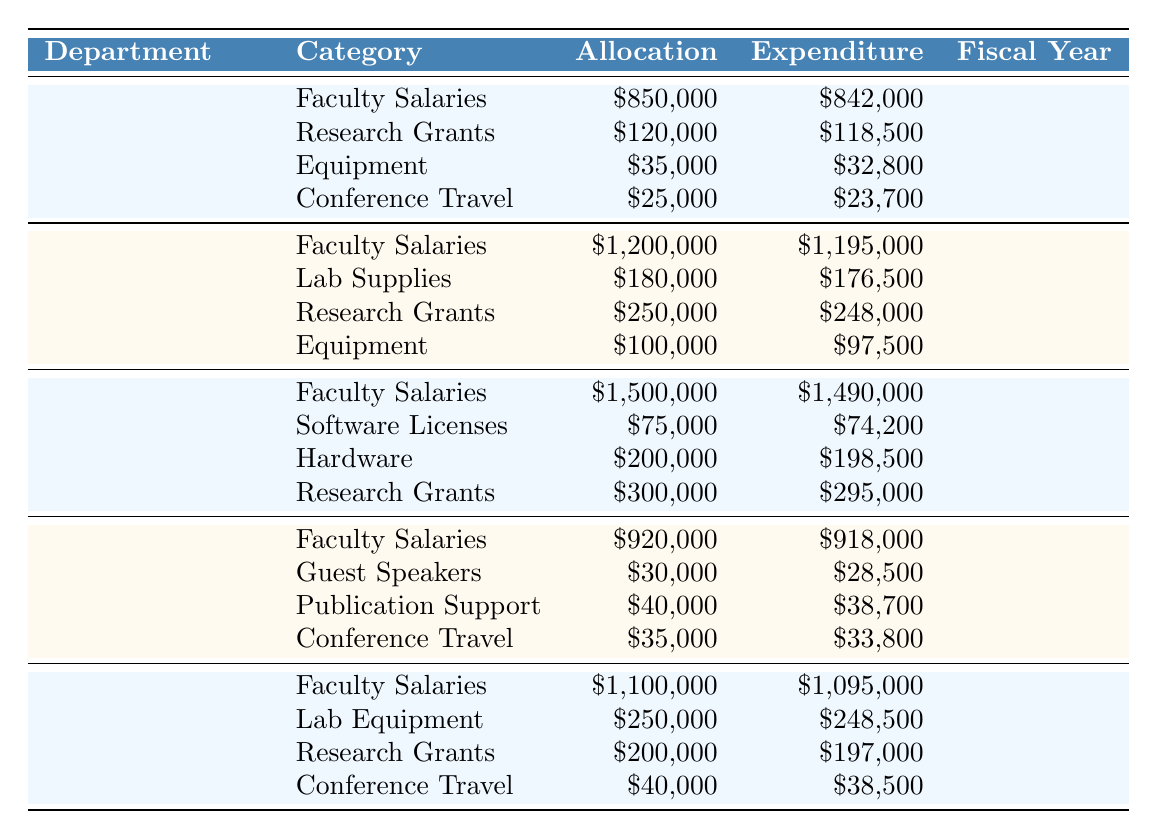What is the total allocation for the Biology department? The allocation for Biology includes Faculty Salaries ($1,200,000), Lab Supplies ($180,000), Research Grants ($250,000), and Equipment ($100,000). Adding them up gives $1,200,000 + $180,000 + $250,000 + $100,000 = $1,730,000.
Answer: $1,730,000 What was the expenditure on Conference Travel in the English department? The English department allocated $35,000 for Conference Travel, and the expenditure was $33,800. Therefore, the expenditure amount is $33,800.
Answer: $33,800 Did the Computer Science department spend less than its allocation on Software Licenses? The Computer Science department allocated $75,000 for Software Licenses and spent $74,200, which is less than the allocation. Therefore, the answer is yes.
Answer: Yes What is the average allocation across all departments for Faculty Salaries? The allocations for Faculty Salaries are: History ($850,000), Biology ($1,200,000), Computer Science ($1,500,000), English ($920,000), and Physics ($1,100,000). These totals add up to $4,570,000. Dividing by 5 departments, the average is $4,570,000 / 5 = $914,000.
Answer: $914,000 Which department has the highest allocation for Research Grants? The Research Grants allocations for each department are: History ($120,000), Biology ($250,000), Computer Science ($300,000), English ($40,000), and Physics ($200,000). The highest among these is Computer Science with $300,000.
Answer: Computer Science What is the total expenditure for the Physics department? The Physics department's expenditures are: Faculty Salaries ($1,095,000), Lab Equipment ($248,500), Research Grants ($197,000), and Conference Travel ($38,500). Summing these gives $1,095,000 + $248,500 + $197,000 + $38,500 = $1,579,000.
Answer: $1,579,000 Is the total allocation for the History department greater than the total expenditure? The total allocation for History is $850,000 + $120,000 + $35,000 + $25,000 = $1,030,000. The total expenditure is $842,000 + $118,500 + $32,800 + $23,700 = $1,016,000. Since $1,030,000 > $1,016,000, the answer is yes.
Answer: Yes What is the difference in allocation and expenditure for the Biology department? The total allocation for Biology is $1,730,000 (as calculated before), and the total expenditure is $1,195,000 + $176,500 + $248,000 + $97,500 = $1,717,000. The difference is $1,730,000 - $1,717,000 = $13,000.
Answer: $13,000 Which category had the highest expenditure in the Computer Science department? In Computer Science, the expenditures are: Faculty Salaries ($1,490,000), Software Licenses ($74,200), Hardware ($198,500), and Research Grants ($295,000). The highest expenditure is Faculty Salaries at $1,490,000.
Answer: Faculty Salaries What percentage of the allocation for English was spent on Guest Speakers? The allocation for Guest Speakers in English is $30,000. The total allocation for English is $920,000 + $30,000 + $40,000 + $35,000 = $1,025,000. The percentage spent is ($28,500 / $1,025,000) * 100 ≈ 2.78%.
Answer: Approximately 2.78% Which department utilized its equipment budget most efficiently, based on the percentage of expenditure to allocation? For each department, the efficiency can be calculated: History (94.3%), Biology (96.4%), Computer Science (99.25%), English (96.75%), and Physics (99.4%). The highest efficiency percentage goes to Computer Science with 99.25%.
Answer: Computer Science 